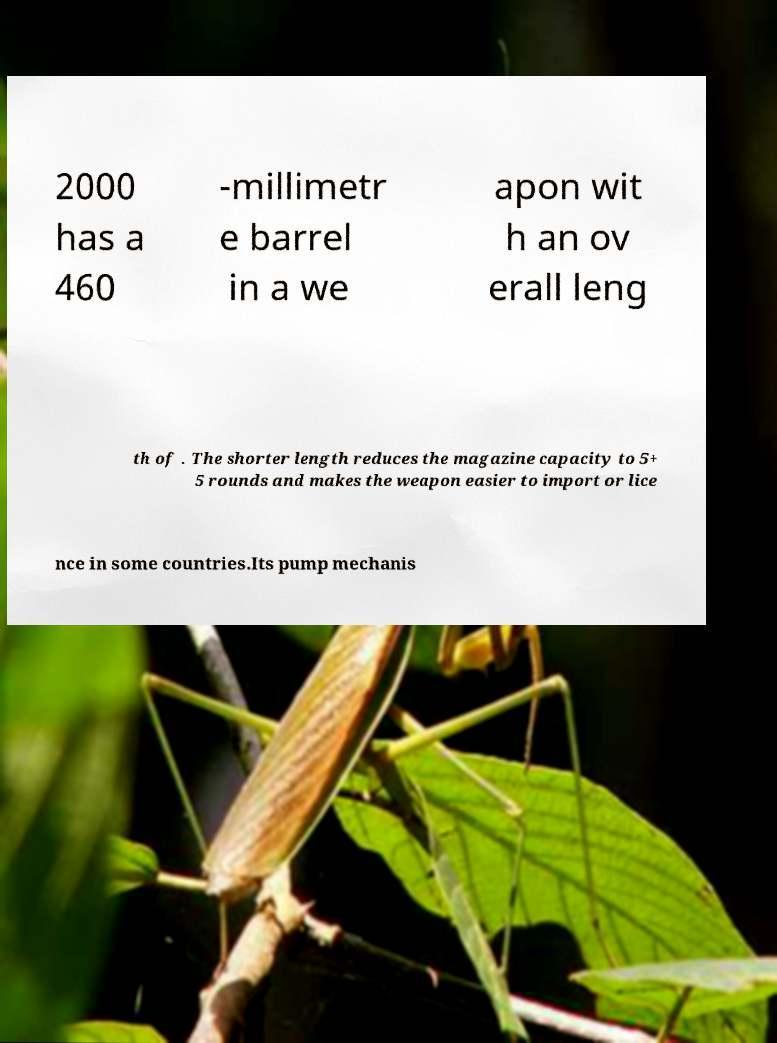Could you extract and type out the text from this image? 2000 has a 460 -millimetr e barrel in a we apon wit h an ov erall leng th of . The shorter length reduces the magazine capacity to 5+ 5 rounds and makes the weapon easier to import or lice nce in some countries.Its pump mechanis 